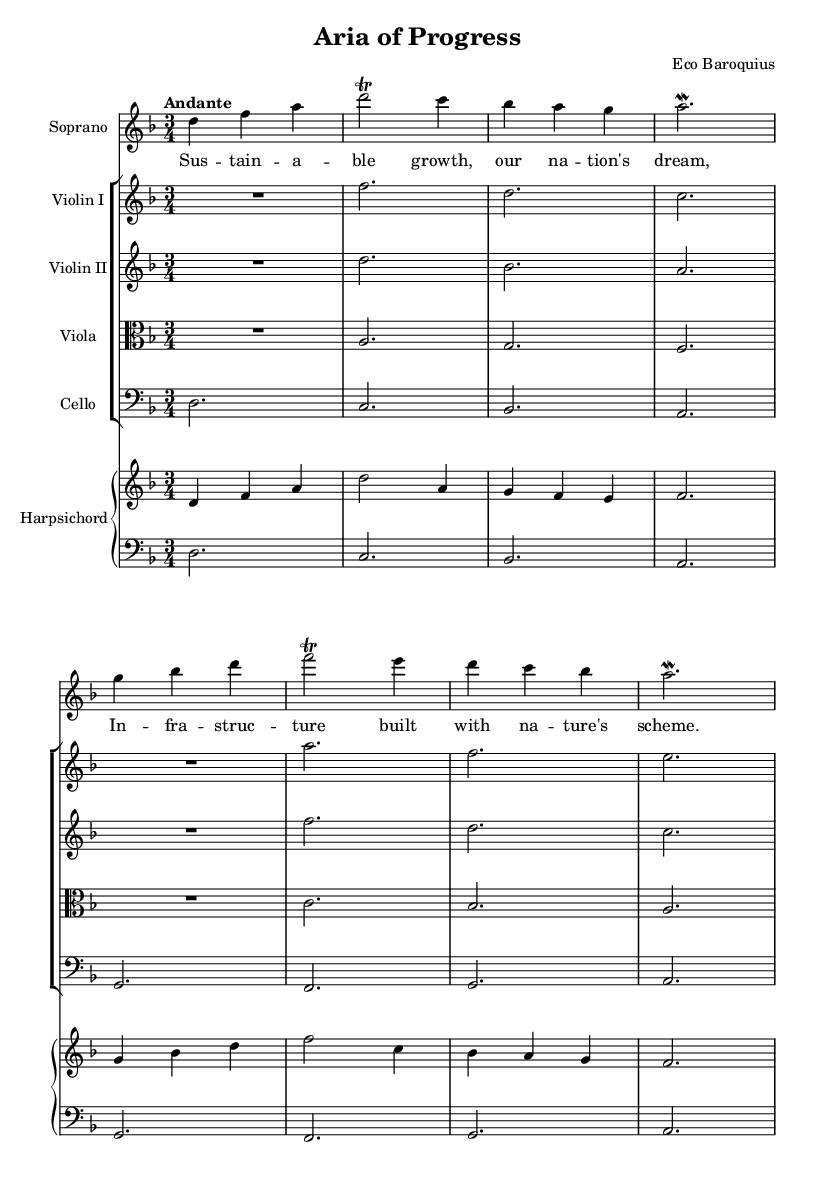What is the key signature of this music? The key signature is indicated at the beginning of the score. It shows two flats, which corresponds to the key of D minor.
Answer: D minor What is the time signature of this piece? The time signature is located at the beginning of the score after the key signature. It is indicated as 3/4, meaning there are three beats per measure, and the quarter note gets one beat.
Answer: 3/4 What is the tempo marking provided in the score? The tempo marking is written at the top of the score in Italian. "Andante" means to perform the piece at a moderate walking speed.
Answer: Andante How many measures are in the soprano part? To find the number of measures, we count the vertical lines that indicate the end of each measure in the soprano part. There are eight vertical lines shown, indicating there are eight measures.
Answer: 8 What instruments are featured in the score? The instruments are listed at the beginning of each staff. The involved instruments are soprano, violin I, violin II, viola, cello, and harpsichord.
Answer: Soprano, violin I, violin II, viola, cello, harpsichord What themes are reflected in the lyrics of the soprano part? The lyrics emphasize sustainable growth and infrastructure that aligns with nature, reflecting environmental themes. This is seen in the phrases mentioned in the lyrics.
Answer: Sustainable growth 